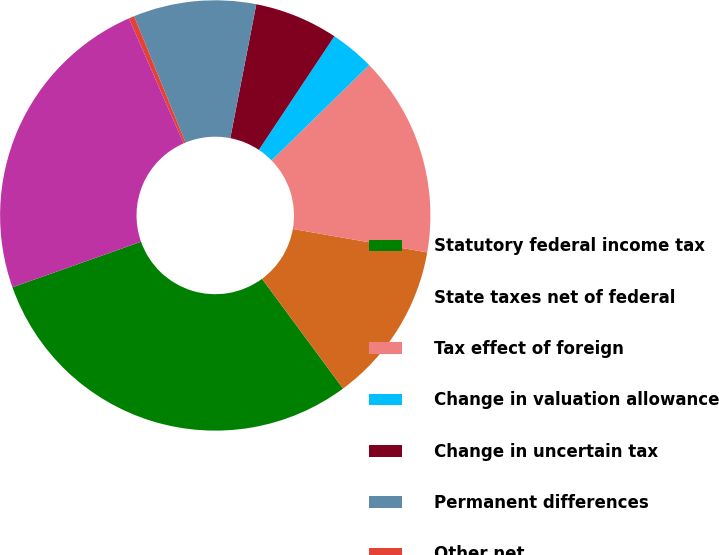Convert chart to OTSL. <chart><loc_0><loc_0><loc_500><loc_500><pie_chart><fcel>Statutory federal income tax<fcel>State taxes net of federal<fcel>Tax effect of foreign<fcel>Change in valuation allowance<fcel>Change in uncertain tax<fcel>Permanent differences<fcel>Other net<fcel>Effective tax rate<nl><fcel>29.7%<fcel>12.13%<fcel>15.06%<fcel>3.35%<fcel>6.28%<fcel>9.21%<fcel>0.42%<fcel>23.84%<nl></chart> 